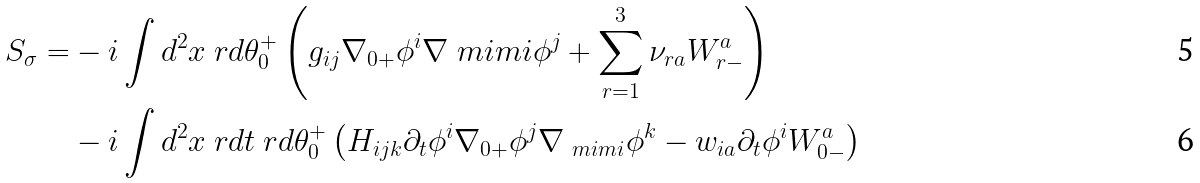<formula> <loc_0><loc_0><loc_500><loc_500>S _ { \sigma } = & - i \int d { ^ { 2 } x \ r d \theta _ { 0 } ^ { + } } \left ( g _ { i j } \nabla _ { 0 + } \phi ^ { i } \nabla _ { \ } m i m i \phi ^ { j } + \sum _ { r = 1 } ^ { 3 } \nu _ { r a } W _ { r - } ^ { a } \right ) \\ & - i \int d { ^ { 2 } x \ r d t \ r d \theta _ { 0 } ^ { + } } \left ( H _ { i j k } \partial _ { t } \phi ^ { i } \nabla _ { 0 + } \phi ^ { j } \nabla _ { \ m i m i } \phi ^ { k } - w _ { i a } \partial _ { t } \phi ^ { i } W _ { 0 - } ^ { a } \right )</formula> 